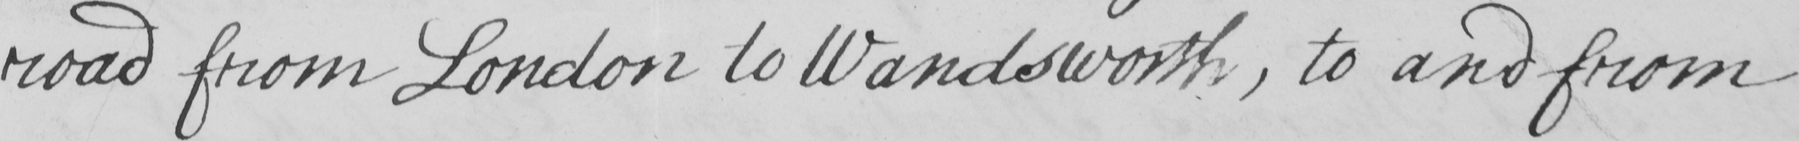What does this handwritten line say? road form London to Wandsworth , to and from 